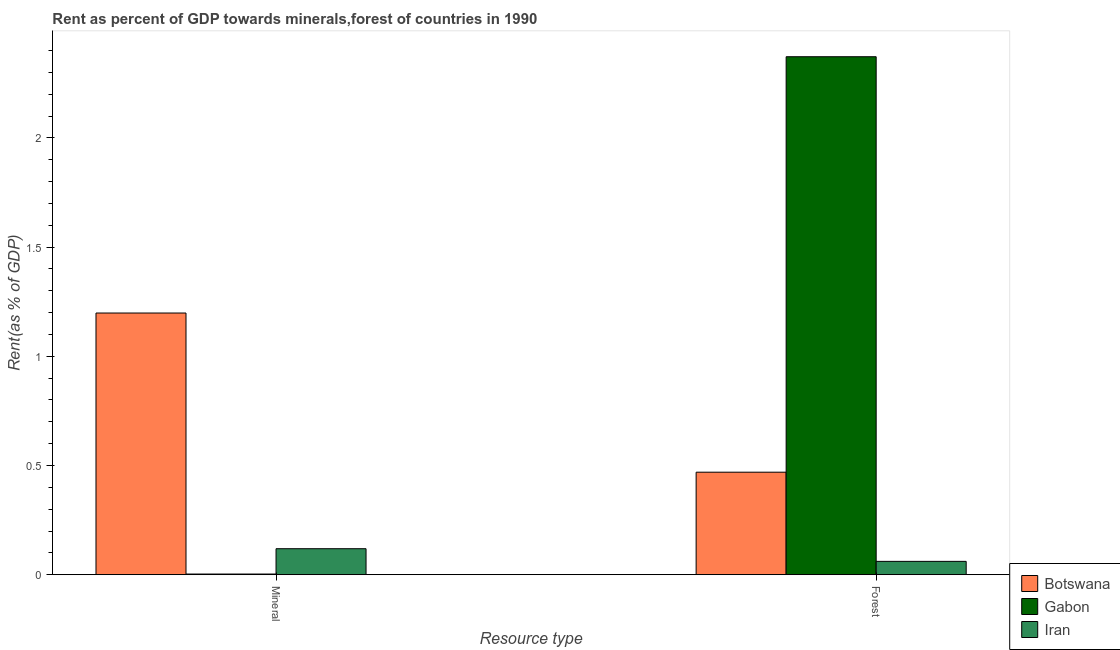Are the number of bars per tick equal to the number of legend labels?
Your answer should be compact. Yes. Are the number of bars on each tick of the X-axis equal?
Provide a short and direct response. Yes. How many bars are there on the 1st tick from the left?
Offer a terse response. 3. How many bars are there on the 1st tick from the right?
Keep it short and to the point. 3. What is the label of the 2nd group of bars from the left?
Ensure brevity in your answer.  Forest. What is the forest rent in Gabon?
Offer a very short reply. 2.37. Across all countries, what is the maximum mineral rent?
Your response must be concise. 1.2. Across all countries, what is the minimum forest rent?
Your answer should be compact. 0.06. In which country was the forest rent maximum?
Provide a succinct answer. Gabon. In which country was the forest rent minimum?
Your response must be concise. Iran. What is the total forest rent in the graph?
Offer a terse response. 2.9. What is the difference between the mineral rent in Iran and that in Botswana?
Your answer should be very brief. -1.08. What is the difference between the mineral rent in Gabon and the forest rent in Iran?
Ensure brevity in your answer.  -0.06. What is the average mineral rent per country?
Make the answer very short. 0.44. What is the difference between the mineral rent and forest rent in Iran?
Give a very brief answer. 0.06. In how many countries, is the mineral rent greater than 2 %?
Make the answer very short. 0. What is the ratio of the mineral rent in Gabon to that in Iran?
Your answer should be very brief. 0.02. Is the forest rent in Iran less than that in Gabon?
Keep it short and to the point. Yes. In how many countries, is the forest rent greater than the average forest rent taken over all countries?
Offer a very short reply. 1. What does the 2nd bar from the left in Forest represents?
Offer a very short reply. Gabon. What does the 1st bar from the right in Forest represents?
Ensure brevity in your answer.  Iran. Are all the bars in the graph horizontal?
Offer a very short reply. No. How many countries are there in the graph?
Provide a short and direct response. 3. How are the legend labels stacked?
Offer a terse response. Vertical. What is the title of the graph?
Offer a very short reply. Rent as percent of GDP towards minerals,forest of countries in 1990. What is the label or title of the X-axis?
Provide a short and direct response. Resource type. What is the label or title of the Y-axis?
Make the answer very short. Rent(as % of GDP). What is the Rent(as % of GDP) of Botswana in Mineral?
Give a very brief answer. 1.2. What is the Rent(as % of GDP) in Gabon in Mineral?
Your response must be concise. 0. What is the Rent(as % of GDP) of Iran in Mineral?
Ensure brevity in your answer.  0.12. What is the Rent(as % of GDP) of Botswana in Forest?
Your response must be concise. 0.47. What is the Rent(as % of GDP) of Gabon in Forest?
Offer a very short reply. 2.37. What is the Rent(as % of GDP) of Iran in Forest?
Your response must be concise. 0.06. Across all Resource type, what is the maximum Rent(as % of GDP) of Botswana?
Keep it short and to the point. 1.2. Across all Resource type, what is the maximum Rent(as % of GDP) in Gabon?
Provide a succinct answer. 2.37. Across all Resource type, what is the maximum Rent(as % of GDP) in Iran?
Give a very brief answer. 0.12. Across all Resource type, what is the minimum Rent(as % of GDP) of Botswana?
Keep it short and to the point. 0.47. Across all Resource type, what is the minimum Rent(as % of GDP) in Gabon?
Make the answer very short. 0. Across all Resource type, what is the minimum Rent(as % of GDP) in Iran?
Make the answer very short. 0.06. What is the total Rent(as % of GDP) of Botswana in the graph?
Ensure brevity in your answer.  1.67. What is the total Rent(as % of GDP) in Gabon in the graph?
Offer a terse response. 2.37. What is the total Rent(as % of GDP) of Iran in the graph?
Your answer should be very brief. 0.18. What is the difference between the Rent(as % of GDP) in Botswana in Mineral and that in Forest?
Your answer should be compact. 0.73. What is the difference between the Rent(as % of GDP) in Gabon in Mineral and that in Forest?
Your answer should be very brief. -2.37. What is the difference between the Rent(as % of GDP) in Iran in Mineral and that in Forest?
Keep it short and to the point. 0.06. What is the difference between the Rent(as % of GDP) in Botswana in Mineral and the Rent(as % of GDP) in Gabon in Forest?
Give a very brief answer. -1.17. What is the difference between the Rent(as % of GDP) of Botswana in Mineral and the Rent(as % of GDP) of Iran in Forest?
Offer a terse response. 1.14. What is the difference between the Rent(as % of GDP) of Gabon in Mineral and the Rent(as % of GDP) of Iran in Forest?
Offer a terse response. -0.06. What is the average Rent(as % of GDP) in Botswana per Resource type?
Keep it short and to the point. 0.83. What is the average Rent(as % of GDP) of Gabon per Resource type?
Offer a very short reply. 1.19. What is the average Rent(as % of GDP) in Iran per Resource type?
Give a very brief answer. 0.09. What is the difference between the Rent(as % of GDP) in Botswana and Rent(as % of GDP) in Gabon in Mineral?
Make the answer very short. 1.2. What is the difference between the Rent(as % of GDP) of Botswana and Rent(as % of GDP) of Iran in Mineral?
Your answer should be very brief. 1.08. What is the difference between the Rent(as % of GDP) in Gabon and Rent(as % of GDP) in Iran in Mineral?
Keep it short and to the point. -0.12. What is the difference between the Rent(as % of GDP) of Botswana and Rent(as % of GDP) of Gabon in Forest?
Provide a succinct answer. -1.9. What is the difference between the Rent(as % of GDP) in Botswana and Rent(as % of GDP) in Iran in Forest?
Offer a very short reply. 0.41. What is the difference between the Rent(as % of GDP) of Gabon and Rent(as % of GDP) of Iran in Forest?
Keep it short and to the point. 2.31. What is the ratio of the Rent(as % of GDP) in Botswana in Mineral to that in Forest?
Ensure brevity in your answer.  2.55. What is the ratio of the Rent(as % of GDP) in Gabon in Mineral to that in Forest?
Make the answer very short. 0. What is the ratio of the Rent(as % of GDP) in Iran in Mineral to that in Forest?
Give a very brief answer. 1.95. What is the difference between the highest and the second highest Rent(as % of GDP) in Botswana?
Offer a terse response. 0.73. What is the difference between the highest and the second highest Rent(as % of GDP) of Gabon?
Ensure brevity in your answer.  2.37. What is the difference between the highest and the second highest Rent(as % of GDP) of Iran?
Offer a very short reply. 0.06. What is the difference between the highest and the lowest Rent(as % of GDP) in Botswana?
Offer a terse response. 0.73. What is the difference between the highest and the lowest Rent(as % of GDP) of Gabon?
Your answer should be very brief. 2.37. What is the difference between the highest and the lowest Rent(as % of GDP) in Iran?
Your answer should be very brief. 0.06. 